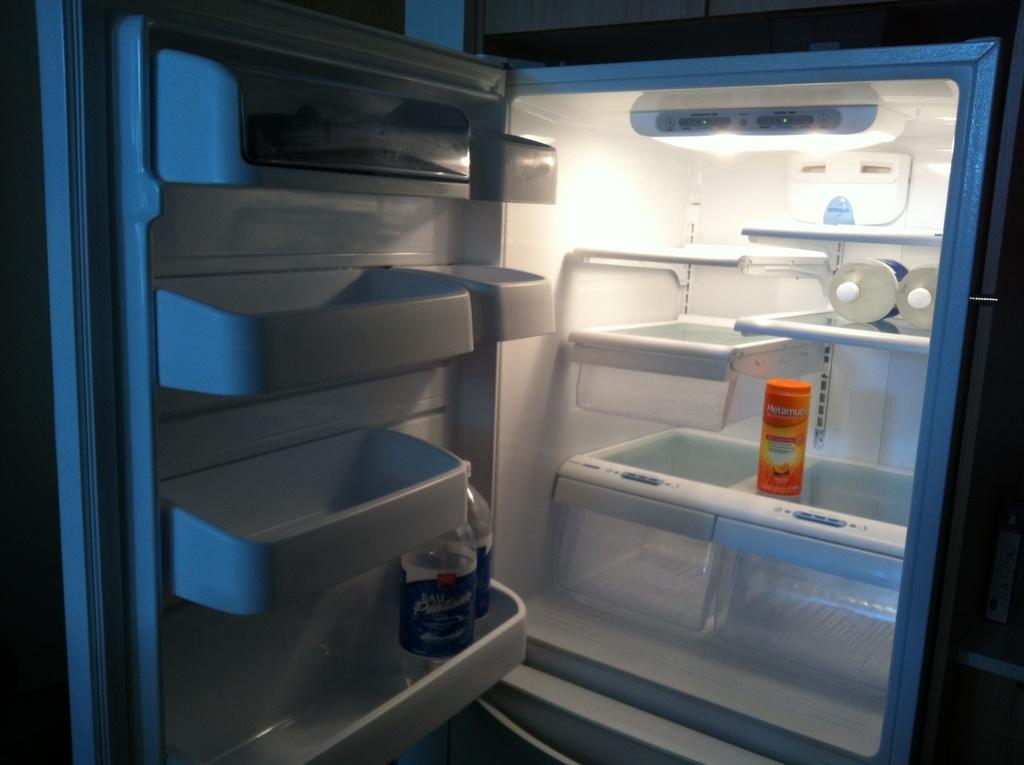Does the orange container contain metamucil?
Give a very brief answer. Yes. 